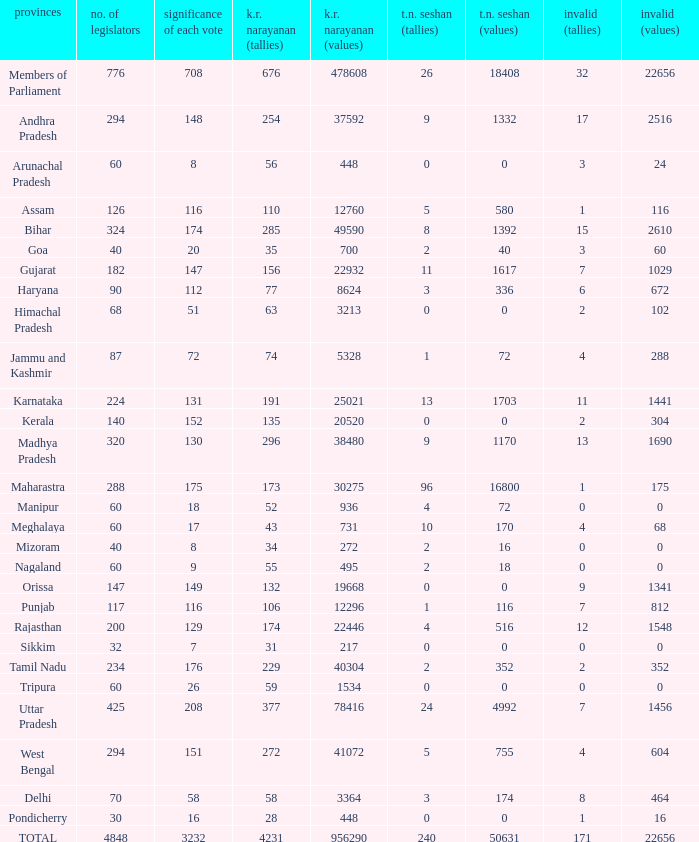Name the most kr votes for value of each vote for 208 377.0. 